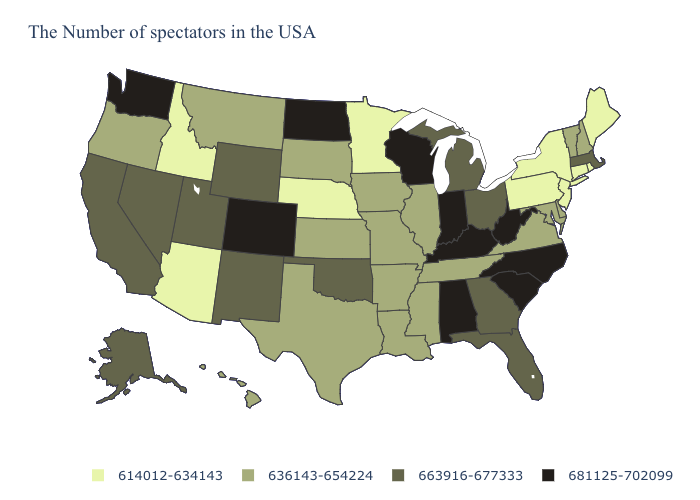Does Georgia have a lower value than Illinois?
Quick response, please. No. Name the states that have a value in the range 614012-634143?
Quick response, please. Maine, Rhode Island, Connecticut, New York, New Jersey, Pennsylvania, Minnesota, Nebraska, Arizona, Idaho. Among the states that border Georgia , which have the highest value?
Be succinct. North Carolina, South Carolina, Alabama. Which states have the lowest value in the USA?
Write a very short answer. Maine, Rhode Island, Connecticut, New York, New Jersey, Pennsylvania, Minnesota, Nebraska, Arizona, Idaho. Does Wisconsin have the same value as Rhode Island?
Quick response, please. No. How many symbols are there in the legend?
Short answer required. 4. What is the value of Mississippi?
Answer briefly. 636143-654224. Does the first symbol in the legend represent the smallest category?
Answer briefly. Yes. What is the value of Hawaii?
Short answer required. 636143-654224. What is the lowest value in the South?
Quick response, please. 636143-654224. What is the value of North Dakota?
Answer briefly. 681125-702099. Does the first symbol in the legend represent the smallest category?
Be succinct. Yes. What is the value of Alaska?
Answer briefly. 663916-677333. Does Missouri have a higher value than Idaho?
Give a very brief answer. Yes. What is the value of Utah?
Be succinct. 663916-677333. 